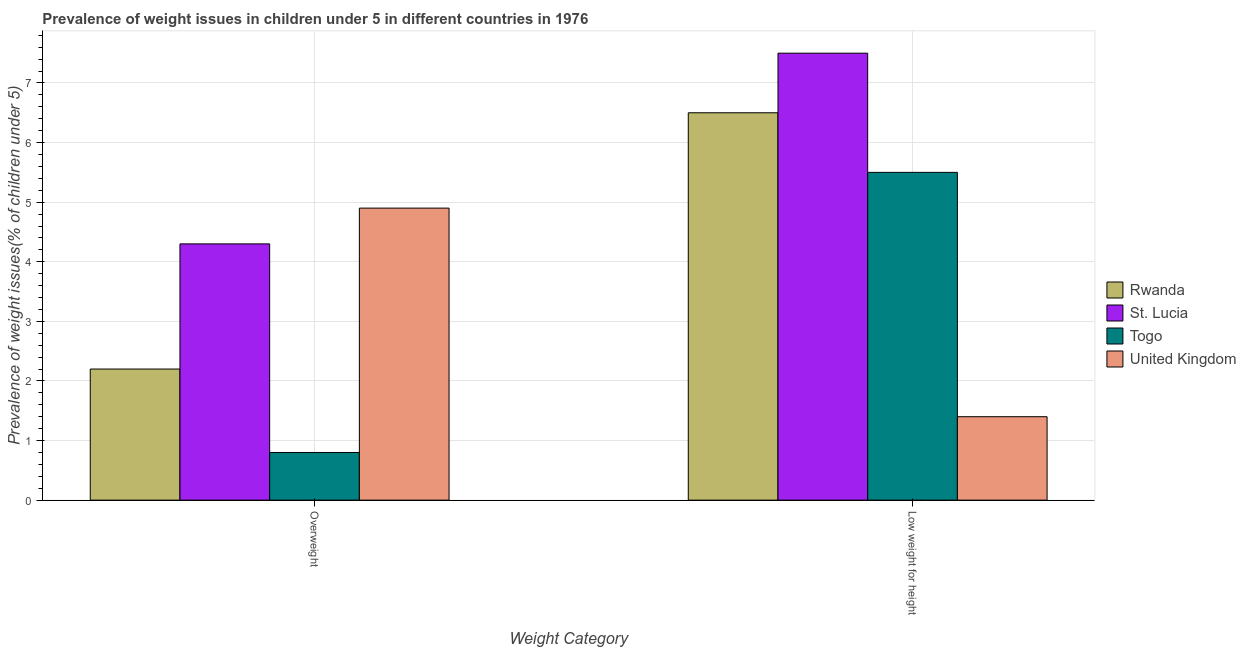How many different coloured bars are there?
Ensure brevity in your answer.  4. How many bars are there on the 1st tick from the right?
Your answer should be very brief. 4. What is the label of the 2nd group of bars from the left?
Your response must be concise. Low weight for height. Across all countries, what is the maximum percentage of overweight children?
Make the answer very short. 4.9. Across all countries, what is the minimum percentage of overweight children?
Make the answer very short. 0.8. In which country was the percentage of underweight children minimum?
Provide a short and direct response. United Kingdom. What is the total percentage of overweight children in the graph?
Ensure brevity in your answer.  12.2. What is the difference between the percentage of underweight children in St. Lucia and that in United Kingdom?
Provide a succinct answer. 6.1. What is the difference between the percentage of overweight children in St. Lucia and the percentage of underweight children in Rwanda?
Offer a terse response. -2.2. What is the average percentage of underweight children per country?
Your response must be concise. 5.22. What is the difference between the percentage of overweight children and percentage of underweight children in United Kingdom?
Your answer should be very brief. 3.5. What is the ratio of the percentage of underweight children in St. Lucia to that in Togo?
Your answer should be very brief. 1.36. Is the percentage of overweight children in St. Lucia less than that in Rwanda?
Provide a short and direct response. No. In how many countries, is the percentage of underweight children greater than the average percentage of underweight children taken over all countries?
Offer a very short reply. 3. What does the 2nd bar from the left in Low weight for height represents?
Provide a short and direct response. St. Lucia. What does the 3rd bar from the right in Overweight represents?
Provide a short and direct response. St. Lucia. How many bars are there?
Provide a succinct answer. 8. How many countries are there in the graph?
Ensure brevity in your answer.  4. Does the graph contain any zero values?
Your answer should be very brief. No. Does the graph contain grids?
Keep it short and to the point. Yes. Where does the legend appear in the graph?
Your answer should be compact. Center right. How are the legend labels stacked?
Provide a succinct answer. Vertical. What is the title of the graph?
Provide a short and direct response. Prevalence of weight issues in children under 5 in different countries in 1976. What is the label or title of the X-axis?
Make the answer very short. Weight Category. What is the label or title of the Y-axis?
Give a very brief answer. Prevalence of weight issues(% of children under 5). What is the Prevalence of weight issues(% of children under 5) of Rwanda in Overweight?
Your answer should be compact. 2.2. What is the Prevalence of weight issues(% of children under 5) of St. Lucia in Overweight?
Your answer should be very brief. 4.3. What is the Prevalence of weight issues(% of children under 5) in Togo in Overweight?
Offer a very short reply. 0.8. What is the Prevalence of weight issues(% of children under 5) in United Kingdom in Overweight?
Ensure brevity in your answer.  4.9. What is the Prevalence of weight issues(% of children under 5) of Rwanda in Low weight for height?
Ensure brevity in your answer.  6.5. What is the Prevalence of weight issues(% of children under 5) in United Kingdom in Low weight for height?
Offer a terse response. 1.4. Across all Weight Category, what is the maximum Prevalence of weight issues(% of children under 5) of St. Lucia?
Your answer should be very brief. 7.5. Across all Weight Category, what is the maximum Prevalence of weight issues(% of children under 5) of Togo?
Offer a terse response. 5.5. Across all Weight Category, what is the maximum Prevalence of weight issues(% of children under 5) of United Kingdom?
Provide a short and direct response. 4.9. Across all Weight Category, what is the minimum Prevalence of weight issues(% of children under 5) in Rwanda?
Your answer should be very brief. 2.2. Across all Weight Category, what is the minimum Prevalence of weight issues(% of children under 5) of St. Lucia?
Your answer should be compact. 4.3. Across all Weight Category, what is the minimum Prevalence of weight issues(% of children under 5) in Togo?
Offer a terse response. 0.8. Across all Weight Category, what is the minimum Prevalence of weight issues(% of children under 5) in United Kingdom?
Your answer should be compact. 1.4. What is the difference between the Prevalence of weight issues(% of children under 5) in St. Lucia in Overweight and that in Low weight for height?
Your answer should be compact. -3.2. What is the difference between the Prevalence of weight issues(% of children under 5) of United Kingdom in Overweight and that in Low weight for height?
Offer a very short reply. 3.5. What is the average Prevalence of weight issues(% of children under 5) of Rwanda per Weight Category?
Keep it short and to the point. 4.35. What is the average Prevalence of weight issues(% of children under 5) of St. Lucia per Weight Category?
Your answer should be compact. 5.9. What is the average Prevalence of weight issues(% of children under 5) in Togo per Weight Category?
Your answer should be very brief. 3.15. What is the average Prevalence of weight issues(% of children under 5) in United Kingdom per Weight Category?
Ensure brevity in your answer.  3.15. What is the difference between the Prevalence of weight issues(% of children under 5) of Rwanda and Prevalence of weight issues(% of children under 5) of Togo in Overweight?
Your response must be concise. 1.4. What is the difference between the Prevalence of weight issues(% of children under 5) in Rwanda and Prevalence of weight issues(% of children under 5) in United Kingdom in Overweight?
Provide a short and direct response. -2.7. What is the difference between the Prevalence of weight issues(% of children under 5) of St. Lucia and Prevalence of weight issues(% of children under 5) of Togo in Overweight?
Your answer should be compact. 3.5. What is the difference between the Prevalence of weight issues(% of children under 5) of St. Lucia and Prevalence of weight issues(% of children under 5) of United Kingdom in Overweight?
Your response must be concise. -0.6. What is the difference between the Prevalence of weight issues(% of children under 5) in Togo and Prevalence of weight issues(% of children under 5) in United Kingdom in Overweight?
Provide a succinct answer. -4.1. What is the difference between the Prevalence of weight issues(% of children under 5) of Rwanda and Prevalence of weight issues(% of children under 5) of St. Lucia in Low weight for height?
Provide a short and direct response. -1. What is the difference between the Prevalence of weight issues(% of children under 5) of St. Lucia and Prevalence of weight issues(% of children under 5) of Togo in Low weight for height?
Ensure brevity in your answer.  2. What is the difference between the Prevalence of weight issues(% of children under 5) of St. Lucia and Prevalence of weight issues(% of children under 5) of United Kingdom in Low weight for height?
Make the answer very short. 6.1. What is the ratio of the Prevalence of weight issues(% of children under 5) in Rwanda in Overweight to that in Low weight for height?
Offer a very short reply. 0.34. What is the ratio of the Prevalence of weight issues(% of children under 5) of St. Lucia in Overweight to that in Low weight for height?
Your response must be concise. 0.57. What is the ratio of the Prevalence of weight issues(% of children under 5) of Togo in Overweight to that in Low weight for height?
Provide a succinct answer. 0.15. What is the ratio of the Prevalence of weight issues(% of children under 5) of United Kingdom in Overweight to that in Low weight for height?
Offer a very short reply. 3.5. What is the difference between the highest and the second highest Prevalence of weight issues(% of children under 5) in Rwanda?
Your response must be concise. 4.3. What is the difference between the highest and the second highest Prevalence of weight issues(% of children under 5) of St. Lucia?
Offer a very short reply. 3.2. What is the difference between the highest and the second highest Prevalence of weight issues(% of children under 5) in Togo?
Provide a short and direct response. 4.7. What is the difference between the highest and the second highest Prevalence of weight issues(% of children under 5) of United Kingdom?
Make the answer very short. 3.5. 